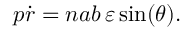<formula> <loc_0><loc_0><loc_500><loc_500>p { \dot { r } } = n a b \, \varepsilon \sin ( \theta ) .</formula> 